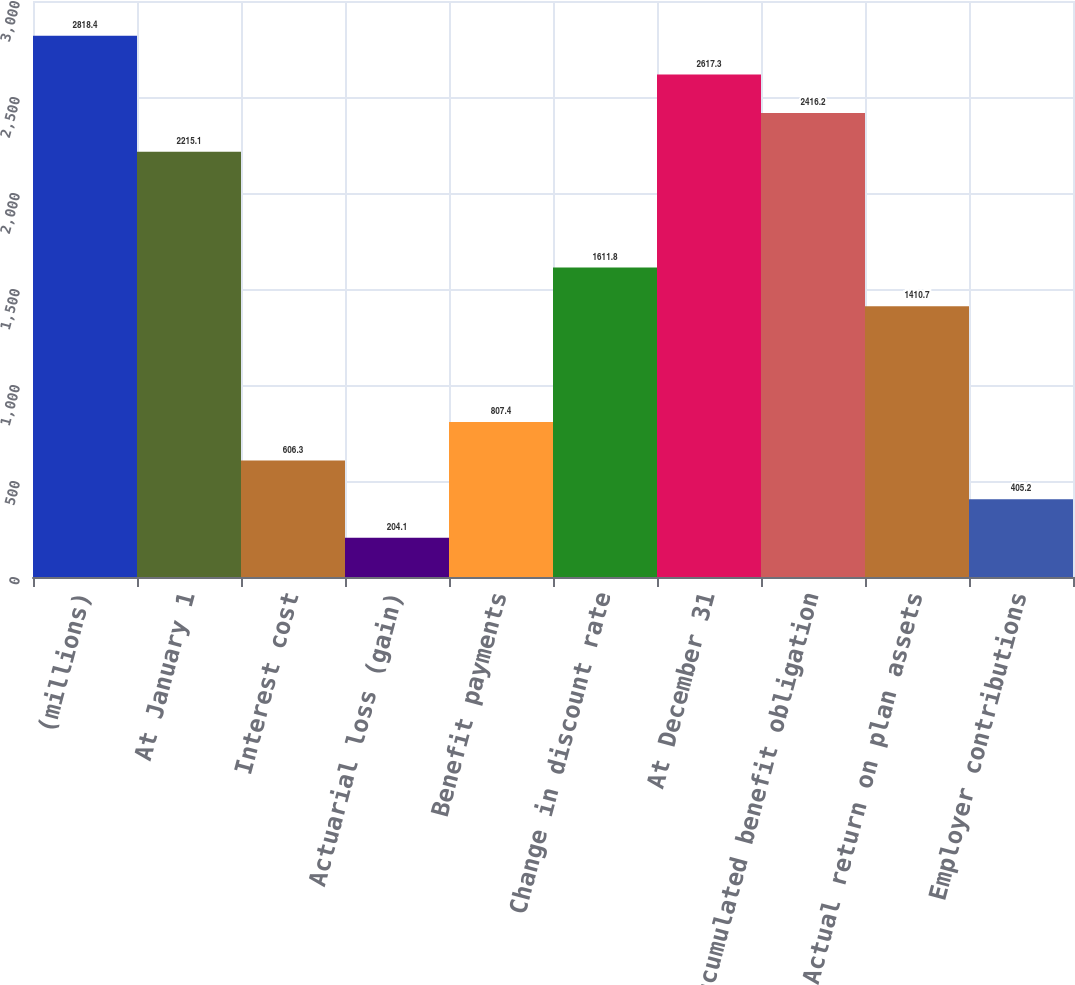Convert chart. <chart><loc_0><loc_0><loc_500><loc_500><bar_chart><fcel>(millions)<fcel>At January 1<fcel>Interest cost<fcel>Actuarial loss (gain)<fcel>Benefit payments<fcel>Change in discount rate<fcel>At December 31<fcel>Accumulated benefit obligation<fcel>Actual return on plan assets<fcel>Employer contributions<nl><fcel>2818.4<fcel>2215.1<fcel>606.3<fcel>204.1<fcel>807.4<fcel>1611.8<fcel>2617.3<fcel>2416.2<fcel>1410.7<fcel>405.2<nl></chart> 